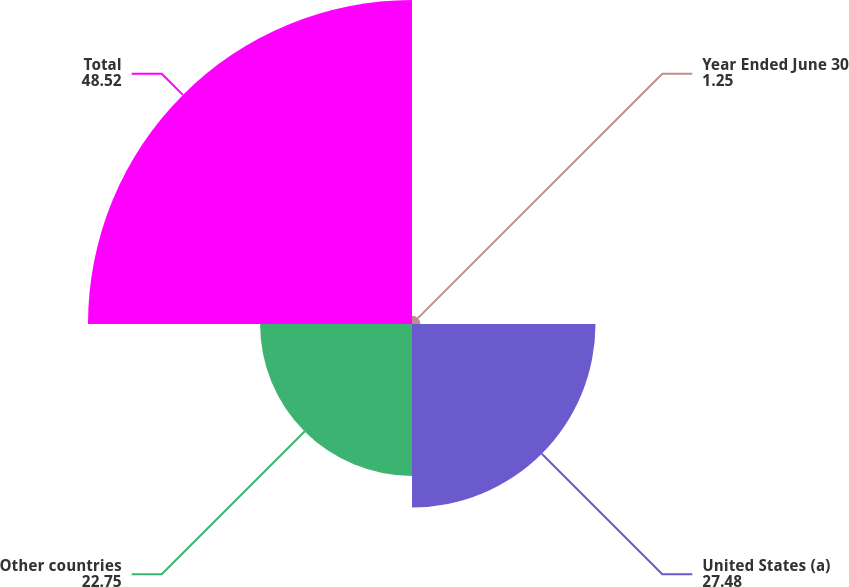Convert chart to OTSL. <chart><loc_0><loc_0><loc_500><loc_500><pie_chart><fcel>Year Ended June 30<fcel>United States (a)<fcel>Other countries<fcel>Total<nl><fcel>1.25%<fcel>27.48%<fcel>22.75%<fcel>48.52%<nl></chart> 